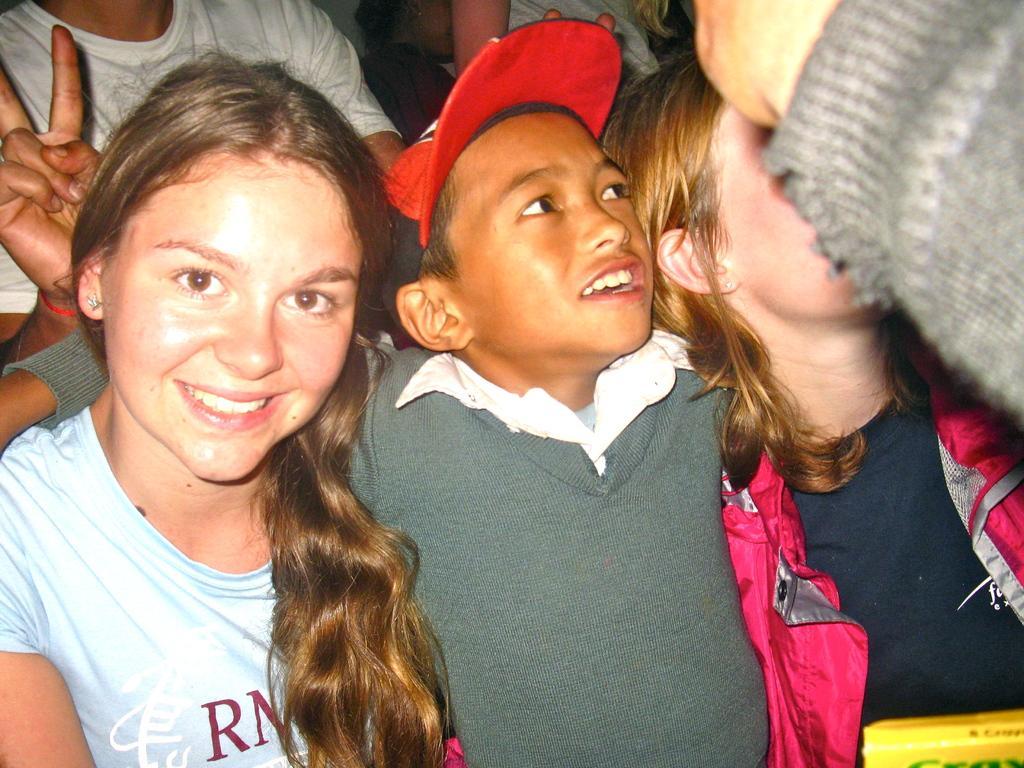Could you give a brief overview of what you see in this image? In this image we can see the children. 